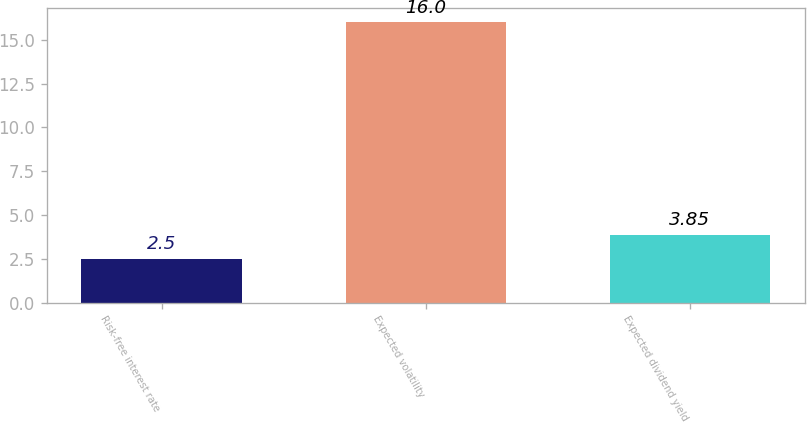Convert chart to OTSL. <chart><loc_0><loc_0><loc_500><loc_500><bar_chart><fcel>Risk-free interest rate<fcel>Expected volatility<fcel>Expected dividend yield<nl><fcel>2.5<fcel>16<fcel>3.85<nl></chart> 